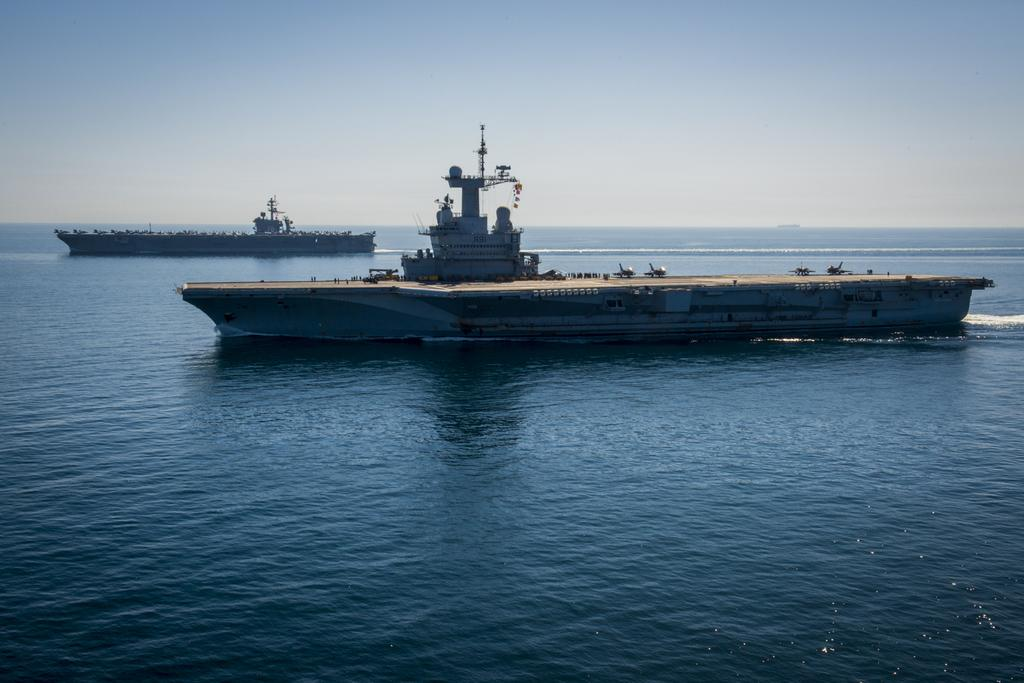What type of vehicles are in the image? There are two steamers in the image. What are the steamers doing in the image? The steamers are sailing in the water. Can you describe the environment in which the steamers are sailing? The water might be in a sea, and the sky is visible at the top of the image. Is there a veil covering the steamers in the image? No, there is no veil present in the image. Is the queen on vacation in the image? There is no reference to a queen or a vacation in the image. 